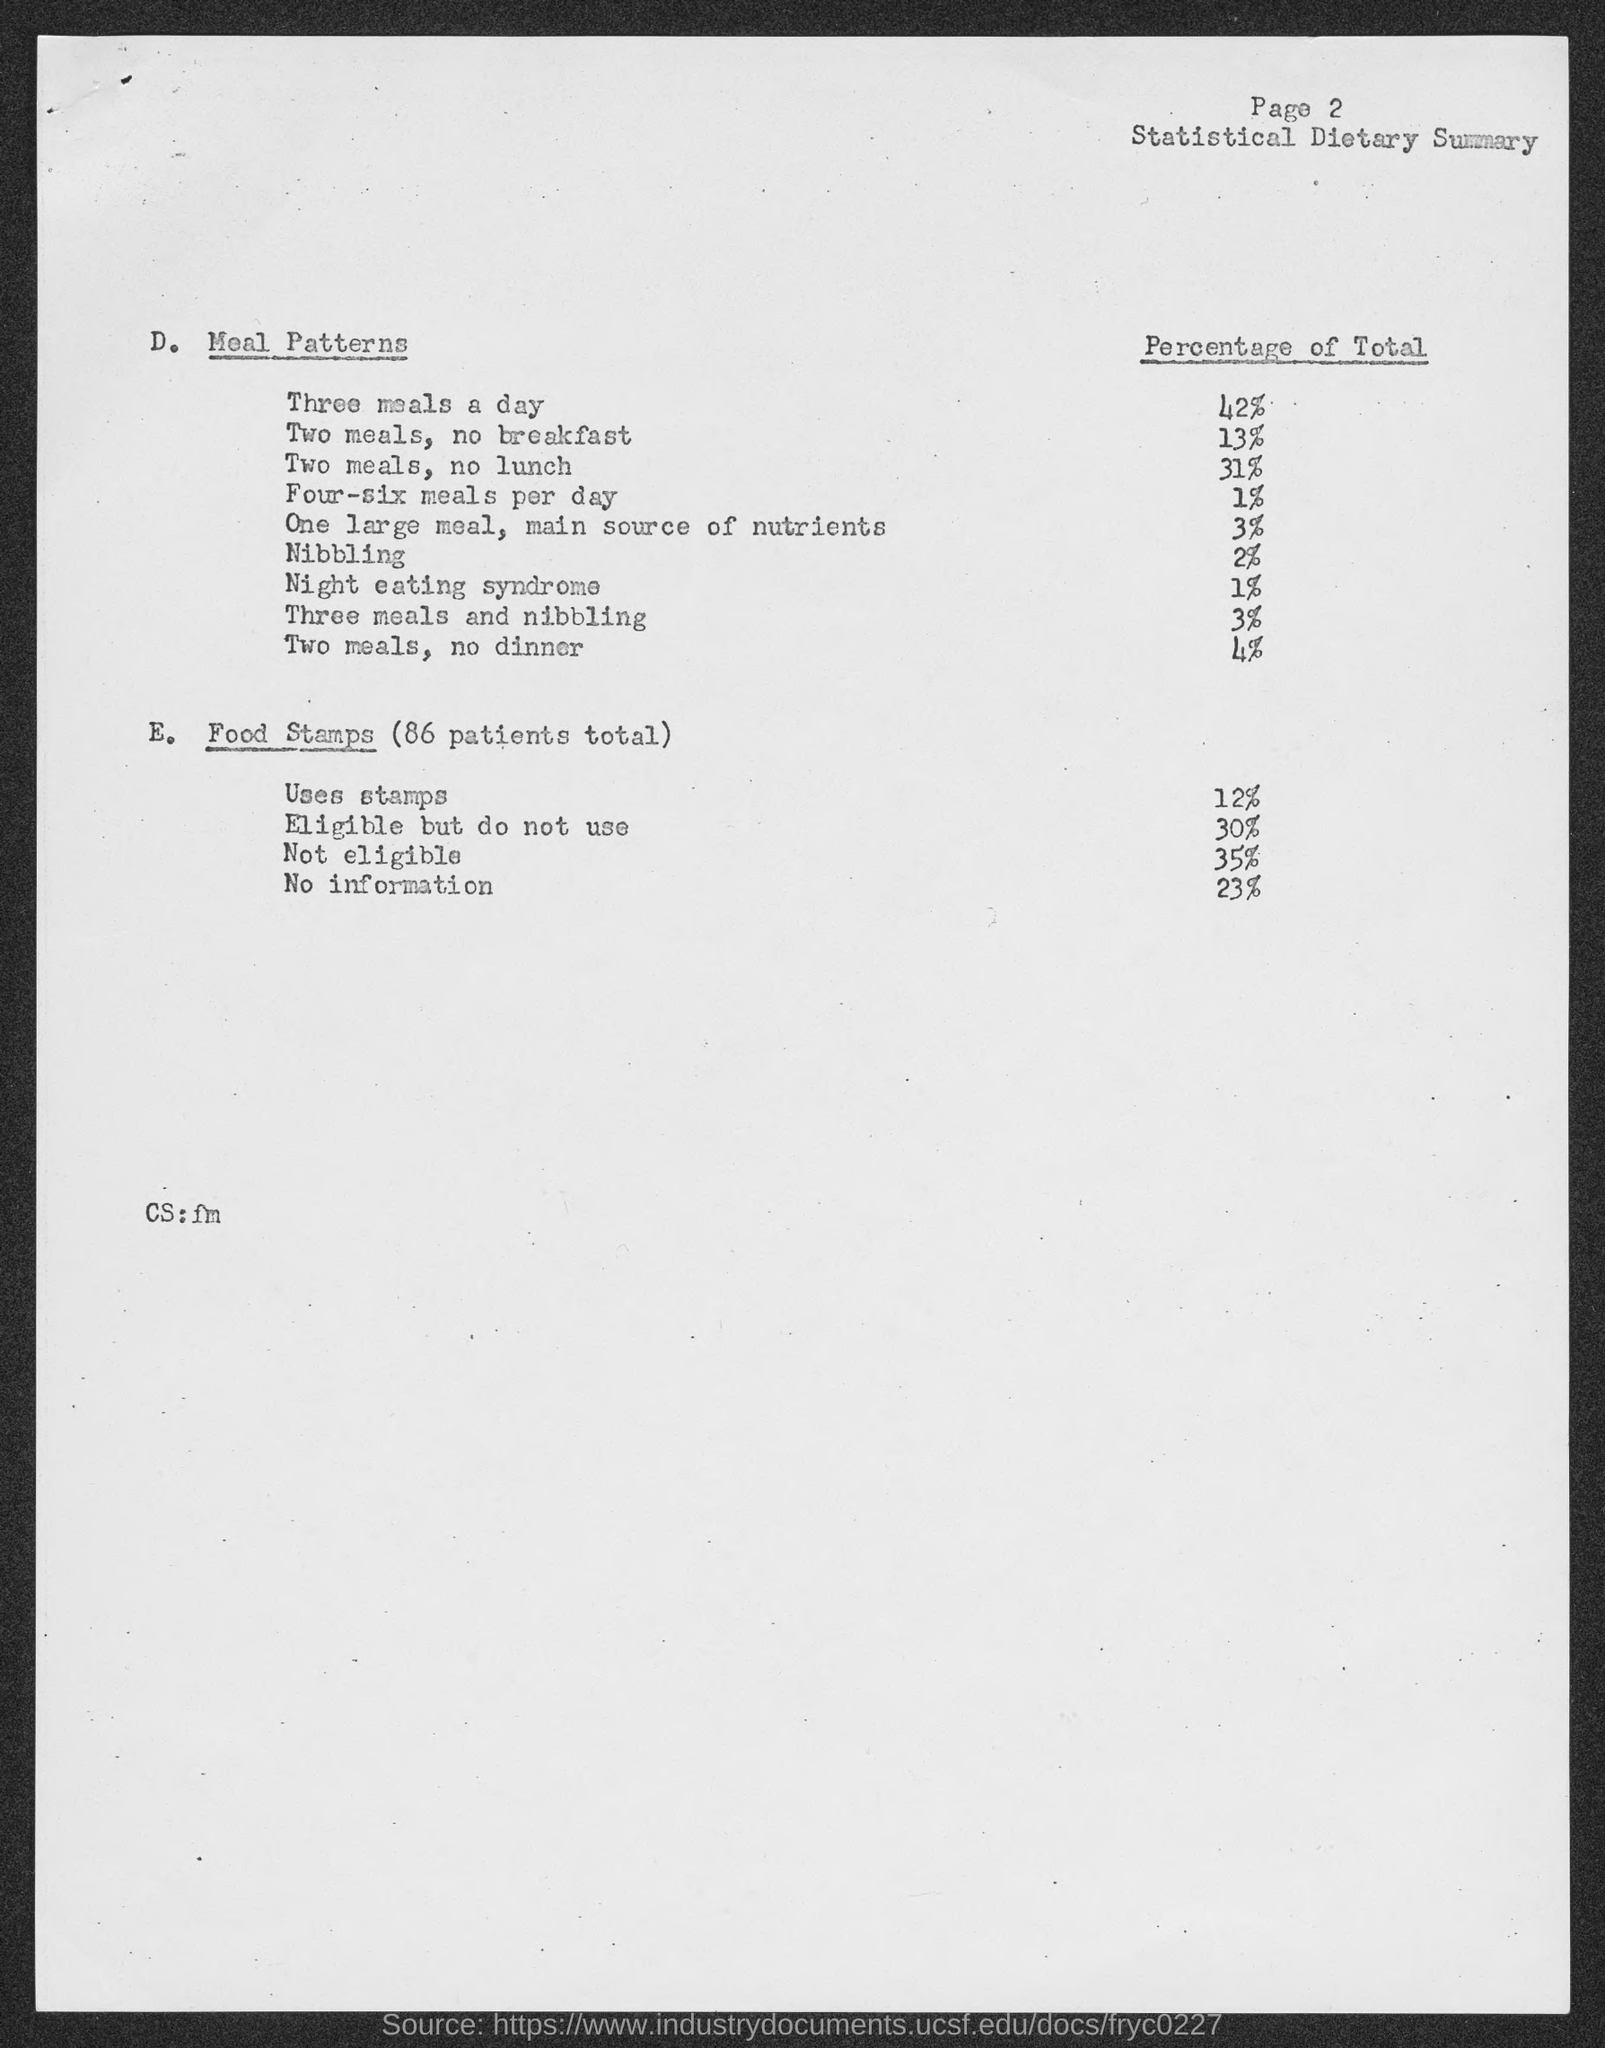Mention a couple of crucial points in this snapshot. According to recent studies, Night Eating Syndrome affects approximately 1% of the population. The page number mentioned in this document is 2. The total of three meals a day meal pattern is 42%. 